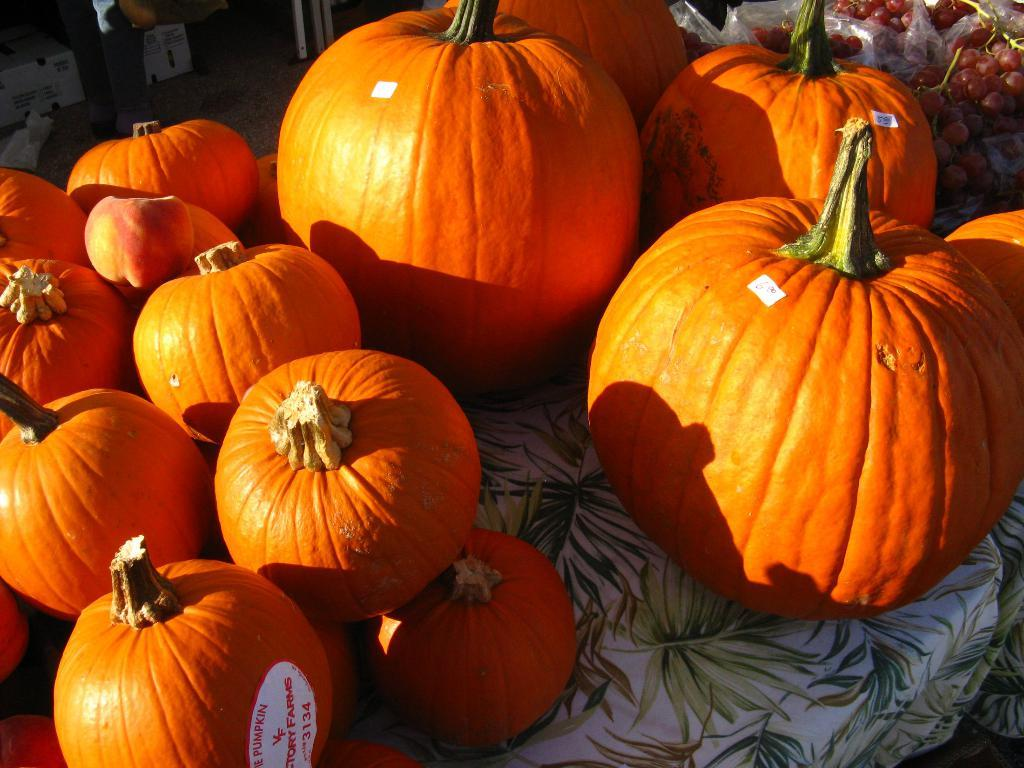What type of fruits and vegetables are in the image? There are pumpkins and grapes in the image. What is covering the table in the image? There is cloth on the table in the image. Can you describe the table in the image? The table is present in the image. What is located in the top left corner of the image? There is a box in the top left corner of the image. What part of the room can be seen in the image? The floor is visible in the image. What is the price of the pumpkins in the image? There is no information about the price of the pumpkins in the image. --- Facts: 1. There is a person in the image. 12. The person is wearing a hat. 13. The person is holding a book. 14. The background of the image is a library. 15. There are shelves filled with books in the background. Absurd Topics: unicorn, spaceship, alien Conversation: Who or what is in the image? There is a person in the image. What is the person wearing? The person is wearing a hat. What is the person holding? The person is holding a book. What can be seen in the background of the image? The background of the image is a library. What else can be seen in the background of the image? There are shelves filled with books in the background. Reasoning: Let's think step by step in order to produce the conversation. We start by identifying the main subject in the image, which is the person. Then, we describe specific details about the person, such as the hat and the book they are holding. Next, we observe the background of the image, which is a library. Finally, we describe additional elements in the background, which are the shelves filled with books. Absurd Question/Answer: Can you see an unicorn in the image? There is no unicorn present in the image. --- Facts: 21. There is a dog in the image. 212. The dog is sitting on a rug. 213. The dog is looking at a toy. 214. The background of the image is a living room. 215. There is a fireplace in the background. Absurd Topics: dragon Conversation: What type of animal is in the image? There is a dog in the image. What is the dog doing in the image? The dog is sitting on a rug. What is the dog looking at in the image? The dog is looking at a toy. What can be seen in the background of the image? The background of the image is a living room. 